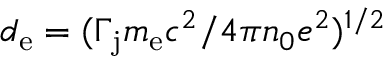Convert formula to latex. <formula><loc_0><loc_0><loc_500><loc_500>d _ { e } = ( \Gamma _ { j } m _ { e } c ^ { 2 } / 4 \pi n _ { 0 } e ^ { 2 } ) ^ { 1 / 2 }</formula> 